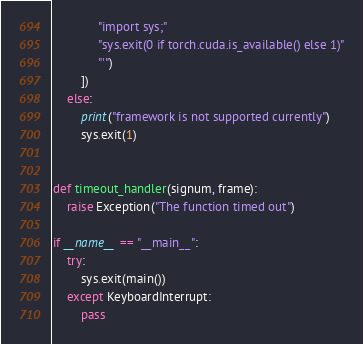<code> <loc_0><loc_0><loc_500><loc_500><_Python_>             "import sys;"
             "sys.exit(0 if torch.cuda.is_available() else 1)"
             "'")
        ])
    else:
        print("framework is not supported currently")
        sys.exit(1)


def timeout_handler(signum, frame):
    raise Exception("The function timed out")

if __name__ == "__main__":
    try:
        sys.exit(main())
    except KeyboardInterrupt:
        pass
</code> 